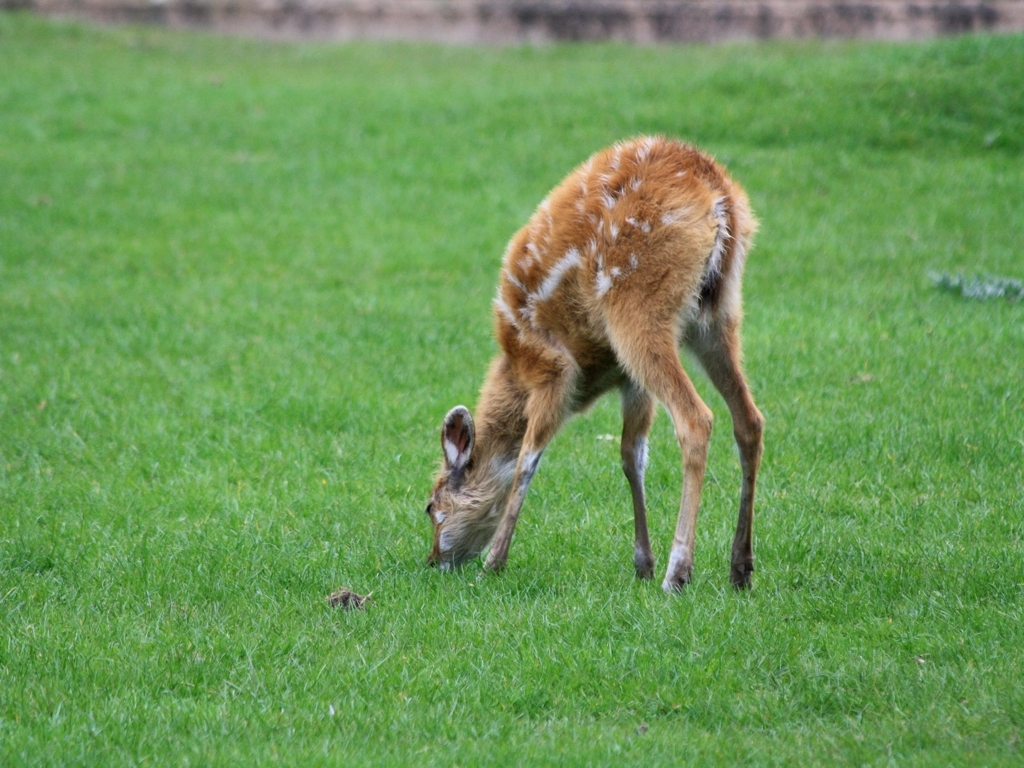Is the image very clear?
A. No
B. Yes The clarity of an image can often depend on both its resolution and the stability of the subject matter during capture. In this case, the image appears quite clear in terms of its focus on the young deer and the details of its fur and surroundings. 